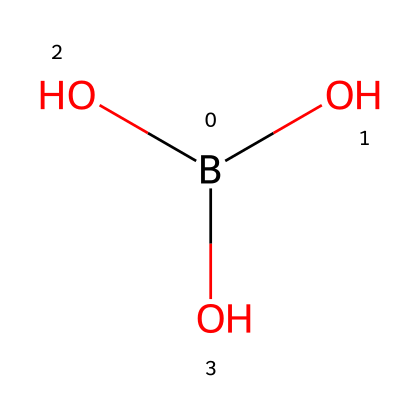What is the name of this chemical? The SMILES representation indicates the presence of boron and hydroxyl groups, which corresponds to boric acid.
Answer: boric acid How many oxygen atoms are in this structure? The SMILES shows three hydroxyl groups (O), indicating there are three oxygen atoms in total.
Answer: three What type of acid is boric acid classified as? Boric acid is classified as a weak acid due to its limited ability to dissociate in water.
Answer: weak acid What element is at the center of this chemical structure? The structure is based on a boron atom (B), which is central to the organization of the molecule containing hydroxyl groups.
Answer: boron How many hydrogen atoms are associated with this acid? Each hydroxyl group contributes one hydrogen atom, totaling three hydrogen atoms in this molecule since there are three (B(O)(O)O).
Answer: three What is the pH characteristic of boric acid in solution? Boric acid typically results in a pH that is less than 7, indicating its acidic nature.
Answer: less than seven Does boric acid completely ionize in water? Boric acid does not completely ionize in water, which is characteristic of weak acids, as it partially dissociates.
Answer: no 